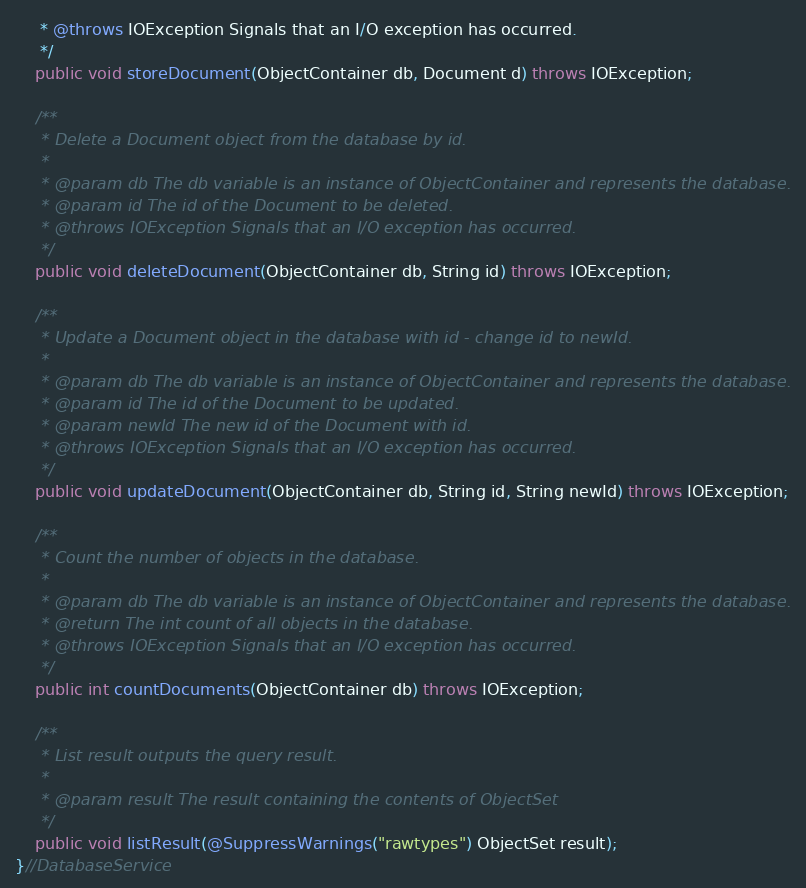Convert code to text. <code><loc_0><loc_0><loc_500><loc_500><_Java_>	 * @throws IOException Signals that an I/O exception has occurred.
	 */
	public void storeDocument(ObjectContainer db, Document d) throws IOException;
	
	/**
	 * Delete a Document object from the database by id.
	 *
	 * @param db The db variable is an instance of ObjectContainer and represents the database.
	 * @param id The id of the Document to be deleted.
	 * @throws IOException Signals that an I/O exception has occurred.
	 */
	public void deleteDocument(ObjectContainer db, String id) throws IOException;
	
	/**
	 * Update a Document object in the database with id - change id to newId.
	 *
	 * @param db The db variable is an instance of ObjectContainer and represents the database.
	 * @param id The id of the Document to be updated.
	 * @param newId The new id of the Document with id.
	 * @throws IOException Signals that an I/O exception has occurred.
	 */
	public void updateDocument(ObjectContainer db, String id, String newId) throws IOException;
	
	/**
	 * Count the number of objects in the database.
	 *
	 * @param db The db variable is an instance of ObjectContainer and represents the database.
	 * @return The int count of all objects in the database.
	 * @throws IOException Signals that an I/O exception has occurred.
	 */
	public int countDocuments(ObjectContainer db) throws IOException;
	
	/**
	 * List result outputs the query result.
	 *
	 * @param result The result containing the contents of ObjectSet
	 */
	public void listResult(@SuppressWarnings("rawtypes") ObjectSet result);
}//DatabaseService</code> 